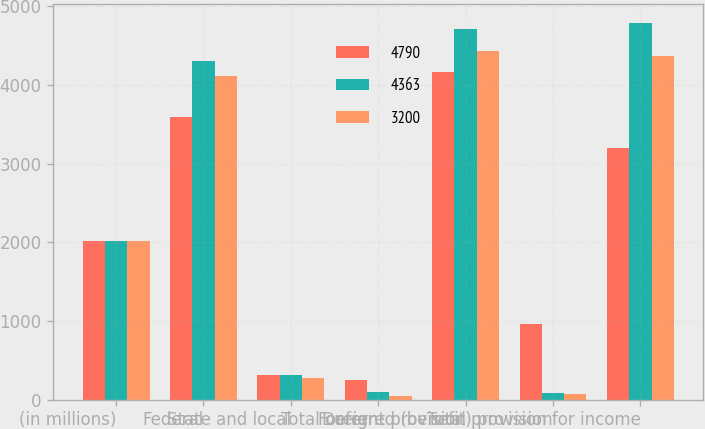Convert chart. <chart><loc_0><loc_0><loc_500><loc_500><stacked_bar_chart><ecel><fcel>(in millions)<fcel>Federal<fcel>State and local<fcel>Foreign<fcel>Total current provision<fcel>Deferred (benefit) provision<fcel>Total provision for income<nl><fcel>4790<fcel>2017<fcel>3597<fcel>314<fcel>254<fcel>4165<fcel>965<fcel>3200<nl><fcel>4363<fcel>2016<fcel>4302<fcel>312<fcel>95<fcel>4709<fcel>81<fcel>4790<nl><fcel>3200<fcel>2015<fcel>4109<fcel>281<fcel>46<fcel>4436<fcel>73<fcel>4363<nl></chart> 